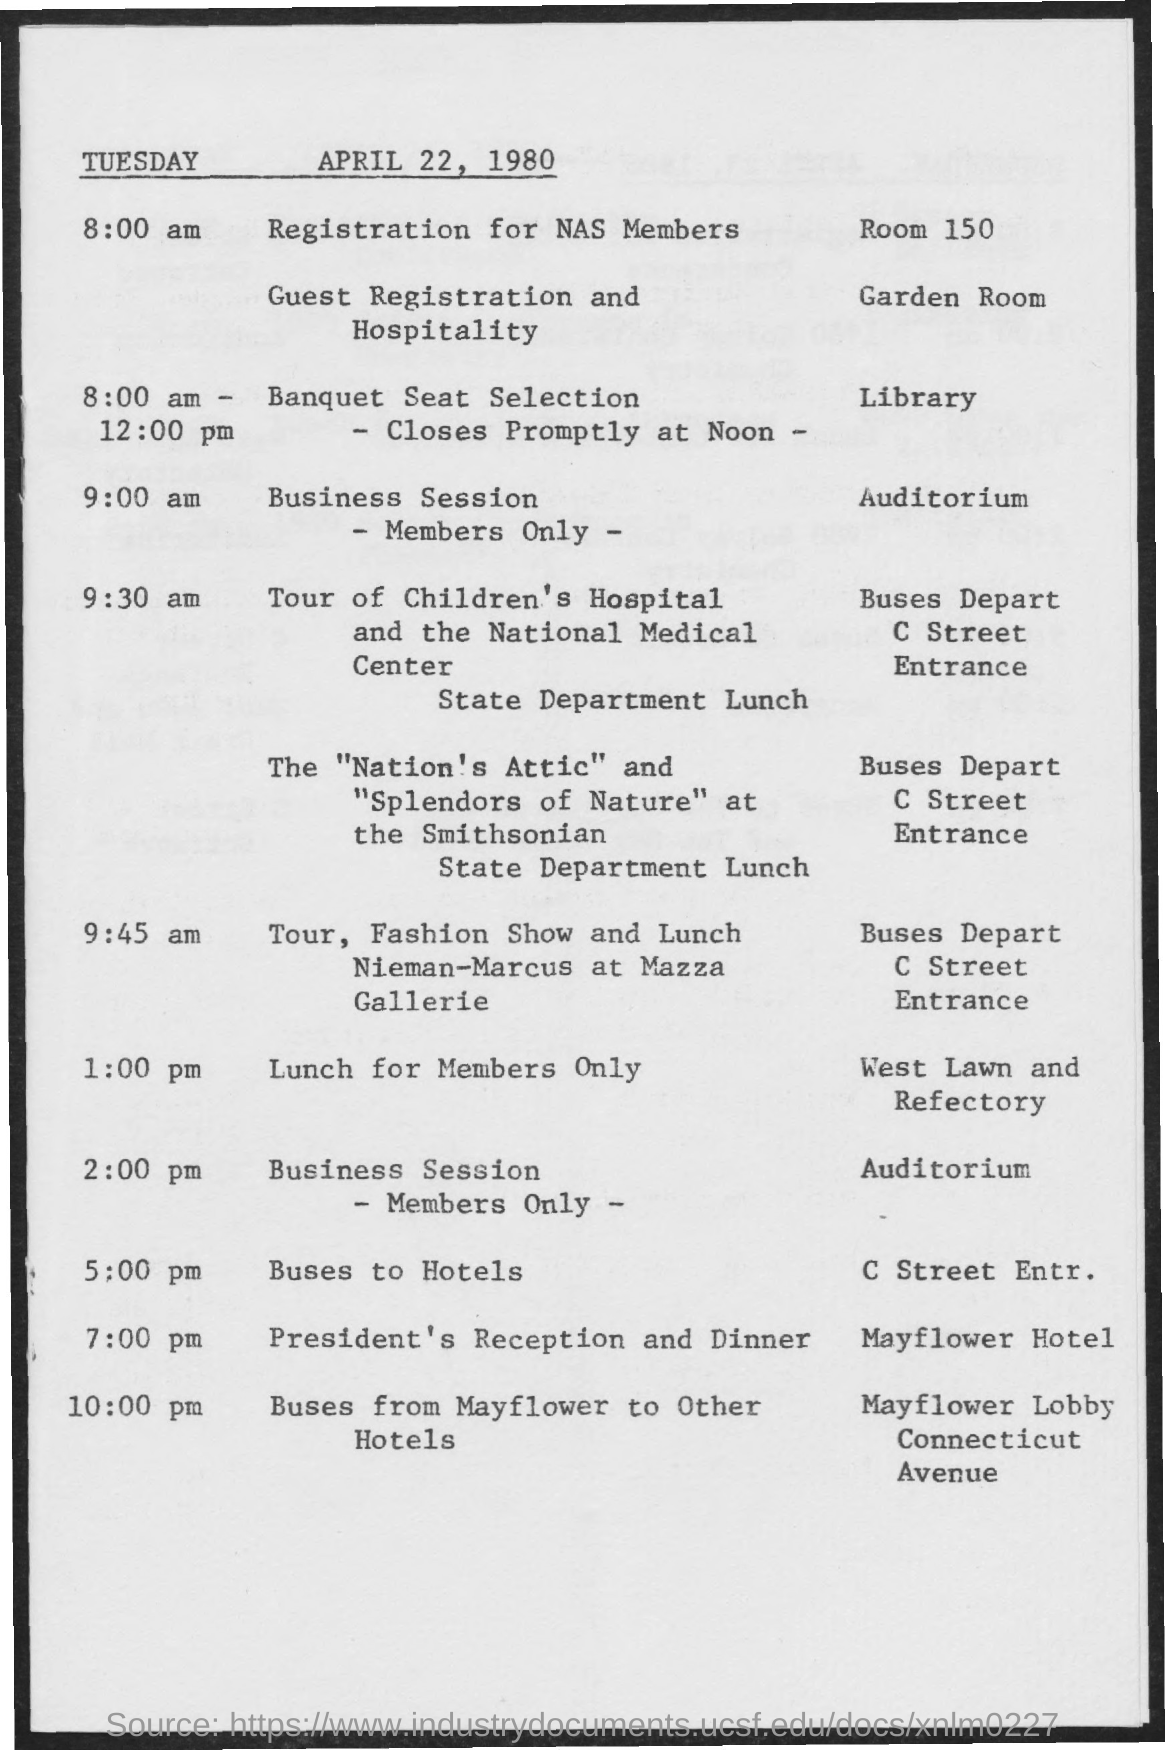Which hotel reception and dinner was arranged?
Offer a terse response. Mayflower Hotel. Which room is set for registration for NAS members?
Make the answer very short. Room 150. Which room is set for registration for Guest registration and hospitality??
Your answer should be very brief. Garden Room. 